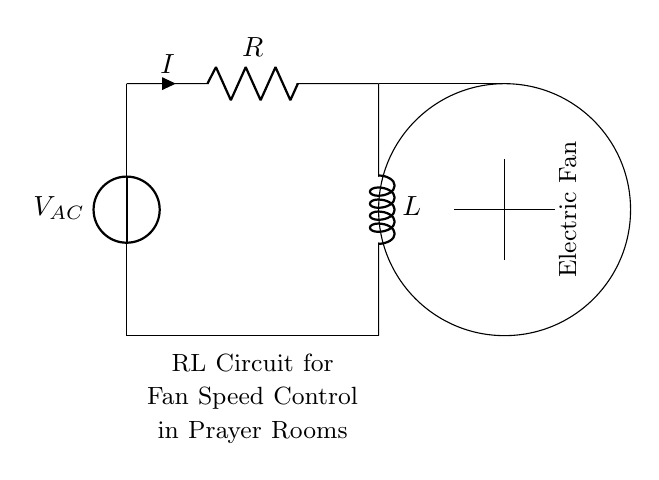What is the voltage source in this circuit? The voltage source is labeled as V_AC, indicating it is an alternating current voltage.
Answer: V_AC What two components are connected in series in this circuit? The components in series are the resistor and the inductor, connected one after the other in the circuit.
Answer: Resistor and Inductor What is the purpose of the inductor in this circuit? The inductor functions primarily to control the current flow over time, which helps in managing the fan speed by its behavior to oppose changes in current.
Answer: Control current flow What is the current in the circuit denoted as? The current in the circuit is denoted by the letter I, illustrated with an arrow indicating the direction of current flow.
Answer: I How does the resistance affect the fan speed? The resistance affects the current flowing through the circuit; increasing resistance will decrease the current and thus lower the fan speed, creating a slower rotation.
Answer: Decreases current What is the function of the electric fan in this circuit? The electric fan is the load that receives power from the RL circuit, allowing for the desired airflow in prayer rooms during activities like Holy Week.
Answer: Provides airflow What happens to the inductor's behavior when the voltage is changed? When the voltage changes, the inductor resists changes in current, causing a delay in the fan speed changes, which smooths the operation of the fan in response to the varying voltage.
Answer: Resists current change 